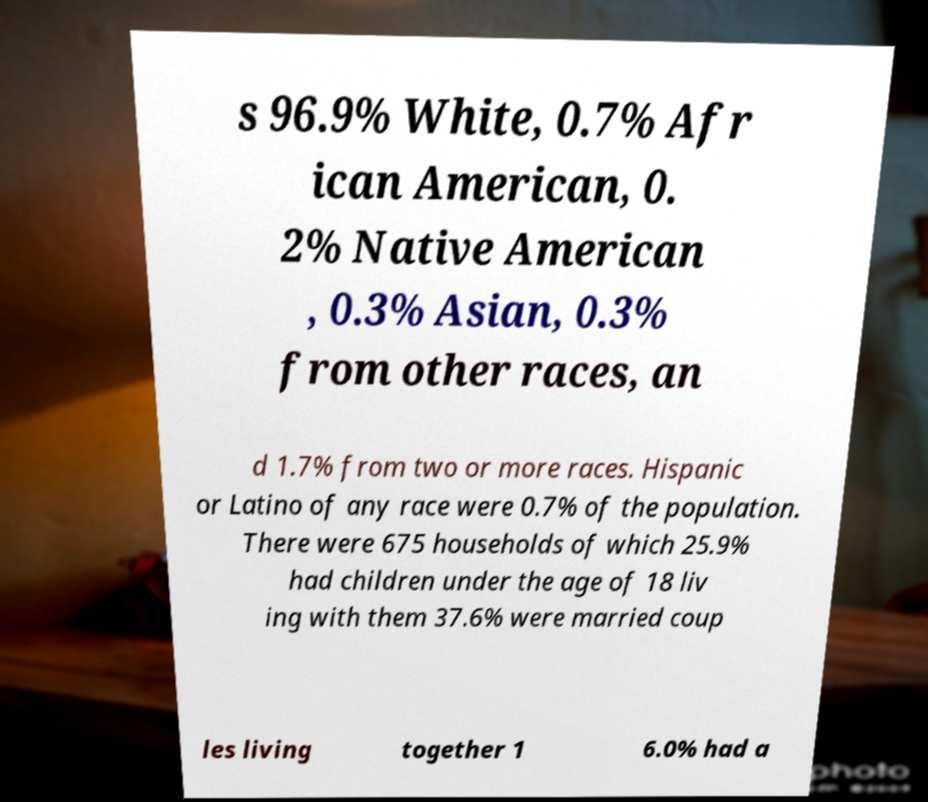Please read and relay the text visible in this image. What does it say? s 96.9% White, 0.7% Afr ican American, 0. 2% Native American , 0.3% Asian, 0.3% from other races, an d 1.7% from two or more races. Hispanic or Latino of any race were 0.7% of the population. There were 675 households of which 25.9% had children under the age of 18 liv ing with them 37.6% were married coup les living together 1 6.0% had a 